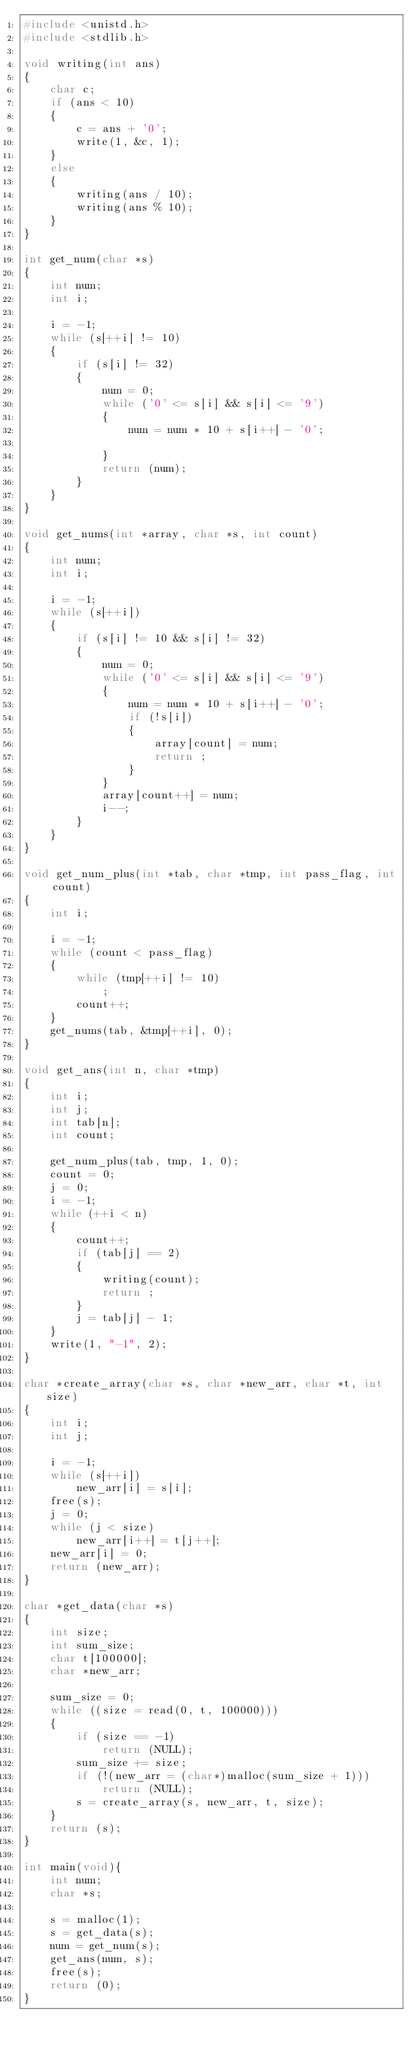Convert code to text. <code><loc_0><loc_0><loc_500><loc_500><_C_>#include <unistd.h>
#include <stdlib.h>

void writing(int ans)
{
    char c;
    if (ans < 10)
    {
        c = ans + '0';
        write(1, &c, 1);
    }
    else
    {
        writing(ans / 10);
        writing(ans % 10);
    }
}

int get_num(char *s)
{
    int num;
    int i;
    
    i = -1;
    while (s[++i] != 10)
    {
        if (s[i] != 32)
        {
            num = 0;
            while ('0' <= s[i] && s[i] <= '9')
            {
                num = num * 10 + s[i++] - '0';
                    
            }
            return (num);
        }
    }  
}

void get_nums(int *array, char *s, int count)
{
    int num;
    int i;
    
    i = -1;
    while (s[++i])
    {
        if (s[i] != 10 && s[i] != 32)
        {
            num = 0;
            while ('0' <= s[i] && s[i] <= '9')
            {
                num = num * 10 + s[i++] - '0';
                if (!s[i])
                {
                    array[count] = num;
                    return ;                    
                }
            }
            array[count++] = num;
            i--;
        }
    }  
}

void get_num_plus(int *tab, char *tmp, int pass_flag, int count)
{
    int i;
    
    i = -1;
    while (count < pass_flag)
    {
        while (tmp[++i] != 10)
            ;
        count++;
    }
    get_nums(tab, &tmp[++i], 0);
}

void get_ans(int n, char *tmp)
{
    int i;
    int j;
    int tab[n];
    int count;
    
    get_num_plus(tab, tmp, 1, 0);
    count = 0;
    j = 0;
    i = -1;
    while (++i < n)
    {
        count++;
        if (tab[j] == 2)
        {
            writing(count);
            return ;
        }
        j = tab[j] - 1;
    }
    write(1, "-1", 2);
}

char *create_array(char *s, char *new_arr, char *t, int size)
{
    int i;
    int j;
    
    i = -1;
    while (s[++i])
        new_arr[i] = s[i];
    free(s);
    j = 0;
    while (j < size)
        new_arr[i++] = t[j++];   
    new_arr[i] = 0;
    return (new_arr);
}

char *get_data(char *s)
{
    int size;
    int sum_size;
    char t[100000];
    char *new_arr;
    
    sum_size = 0;
    while ((size = read(0, t, 100000)))
    {
        if (size == -1)
            return (NULL);
        sum_size += size;
        if (!(new_arr = (char*)malloc(sum_size + 1)))
            return (NULL);
        s = create_array(s, new_arr, t, size);
    }
    return (s);
}

int main(void){
    int num;
    char *s;
    
    s = malloc(1);
    s = get_data(s);
    num = get_num(s);
    get_ans(num, s);
    free(s);
    return (0);
}
</code> 